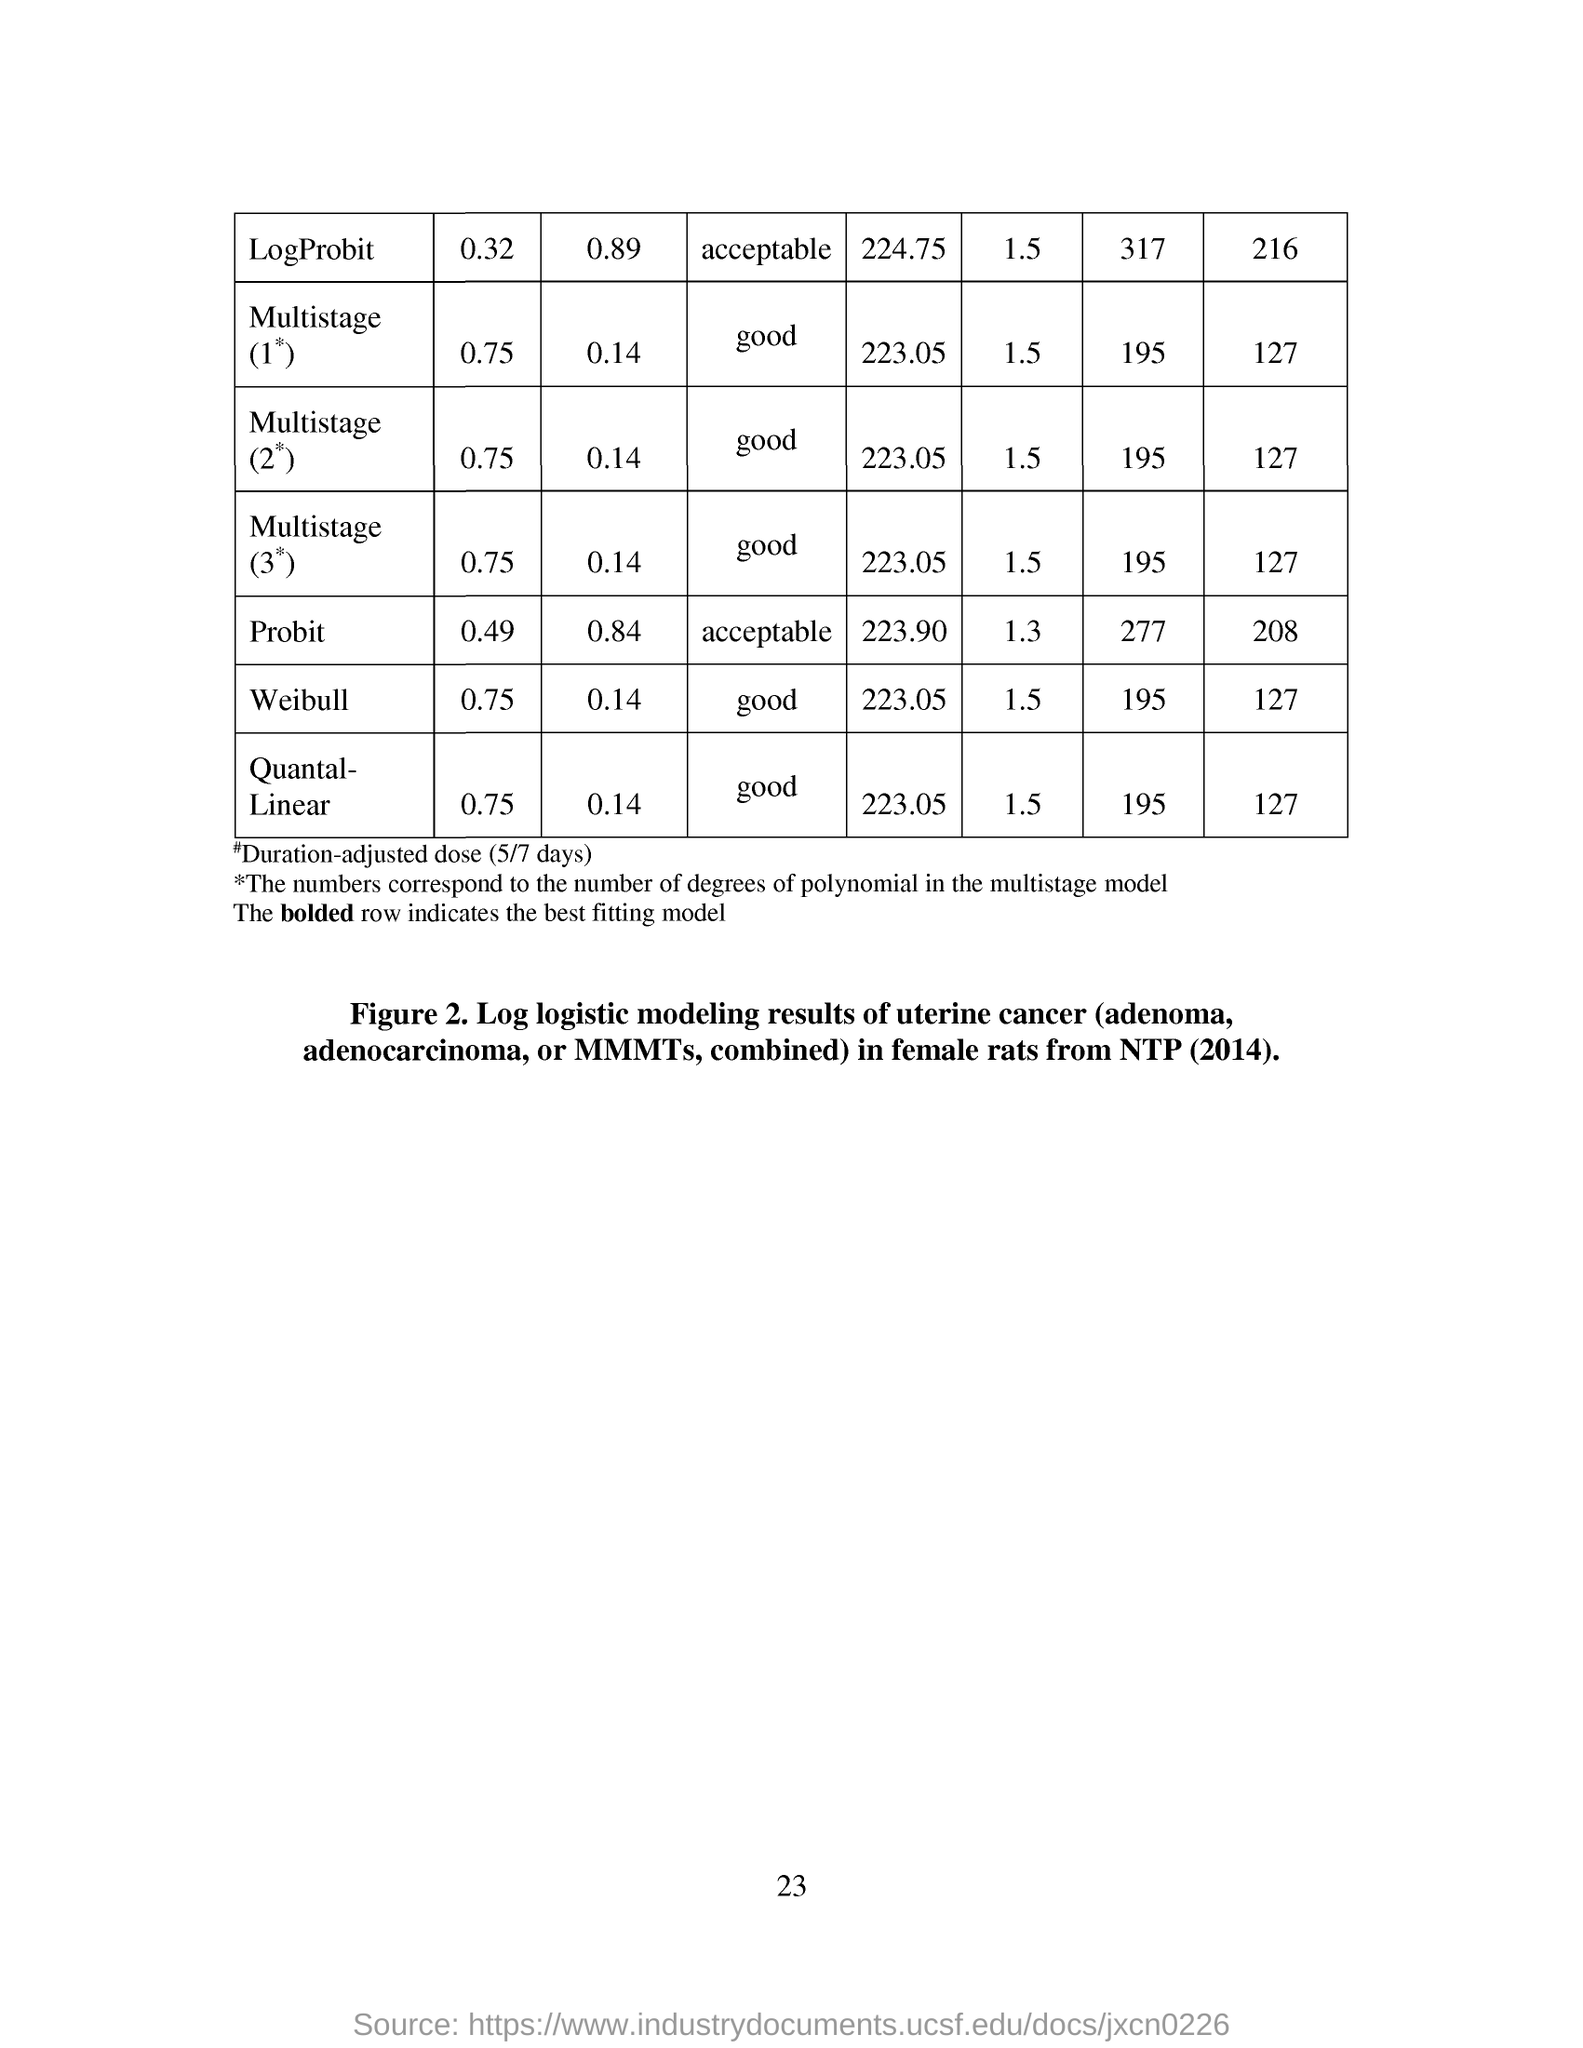Point out several critical features in this image. The page number mentioned in this document is 23. 